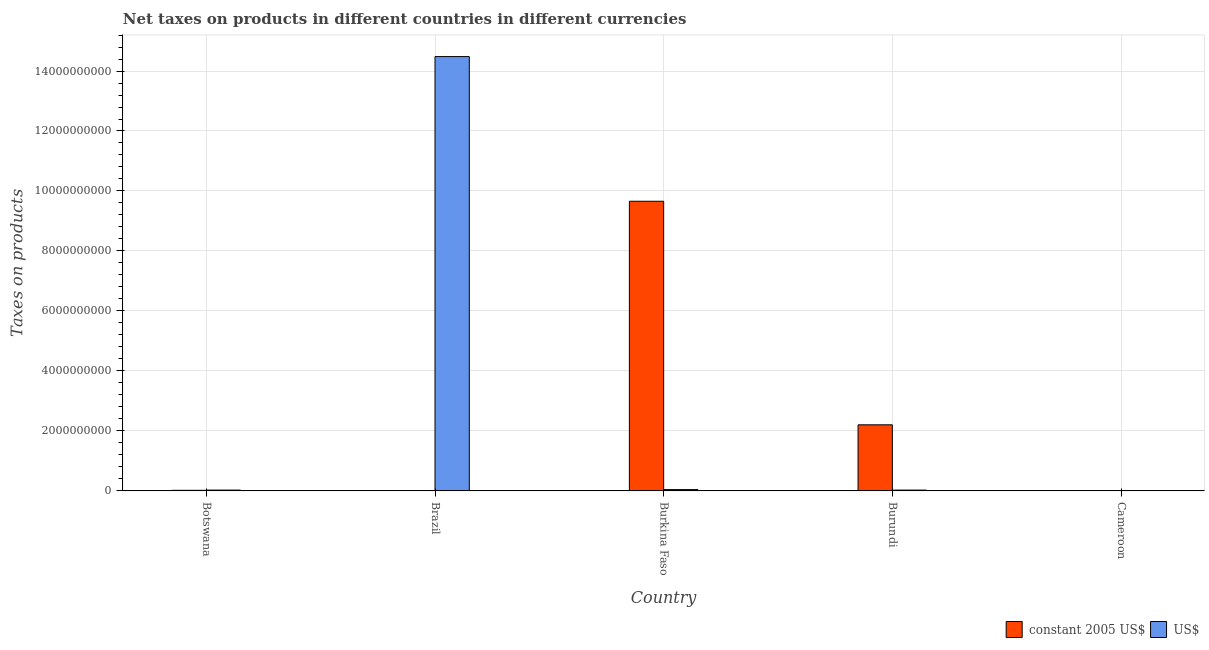How many different coloured bars are there?
Make the answer very short. 2. Are the number of bars per tick equal to the number of legend labels?
Offer a very short reply. No. How many bars are there on the 3rd tick from the left?
Provide a succinct answer. 2. How many bars are there on the 4th tick from the right?
Give a very brief answer. 2. What is the net taxes in constant 2005 us$ in Cameroon?
Your answer should be compact. 0. Across all countries, what is the maximum net taxes in constant 2005 us$?
Offer a terse response. 9.66e+09. Across all countries, what is the minimum net taxes in constant 2005 us$?
Provide a succinct answer. 0. In which country was the net taxes in us$ maximum?
Offer a terse response. Brazil. What is the total net taxes in constant 2005 us$ in the graph?
Ensure brevity in your answer.  1.19e+1. What is the difference between the net taxes in us$ in Botswana and that in Burkina Faso?
Your answer should be very brief. -1.73e+07. What is the difference between the net taxes in constant 2005 us$ in Botswana and the net taxes in us$ in Cameroon?
Offer a terse response. 2.05e+07. What is the average net taxes in us$ per country?
Ensure brevity in your answer.  2.92e+09. What is the difference between the net taxes in us$ and net taxes in constant 2005 us$ in Brazil?
Offer a terse response. 1.45e+1. What is the ratio of the net taxes in constant 2005 us$ in Botswana to that in Burkina Faso?
Offer a very short reply. 0. What is the difference between the highest and the second highest net taxes in us$?
Give a very brief answer. 1.44e+1. What is the difference between the highest and the lowest net taxes in constant 2005 us$?
Provide a short and direct response. 9.66e+09. How many bars are there?
Ensure brevity in your answer.  8. Are the values on the major ticks of Y-axis written in scientific E-notation?
Your response must be concise. No. Does the graph contain grids?
Provide a short and direct response. Yes. How are the legend labels stacked?
Give a very brief answer. Horizontal. What is the title of the graph?
Keep it short and to the point. Net taxes on products in different countries in different currencies. What is the label or title of the Y-axis?
Keep it short and to the point. Taxes on products. What is the Taxes on products of constant 2005 US$ in Botswana?
Your answer should be compact. 2.05e+07. What is the Taxes on products in US$ in Botswana?
Give a very brief answer. 2.77e+07. What is the Taxes on products of constant 2005 US$ in Brazil?
Offer a very short reply. 0.04. What is the Taxes on products in US$ in Brazil?
Offer a terse response. 1.45e+1. What is the Taxes on products of constant 2005 US$ in Burkina Faso?
Provide a short and direct response. 9.66e+09. What is the Taxes on products in US$ in Burkina Faso?
Your response must be concise. 4.51e+07. What is the Taxes on products in constant 2005 US$ in Burundi?
Keep it short and to the point. 2.20e+09. What is the Taxes on products of US$ in Burundi?
Keep it short and to the point. 2.80e+07. Across all countries, what is the maximum Taxes on products of constant 2005 US$?
Your answer should be very brief. 9.66e+09. Across all countries, what is the maximum Taxes on products of US$?
Give a very brief answer. 1.45e+1. Across all countries, what is the minimum Taxes on products of US$?
Offer a terse response. 0. What is the total Taxes on products of constant 2005 US$ in the graph?
Provide a short and direct response. 1.19e+1. What is the total Taxes on products of US$ in the graph?
Make the answer very short. 1.46e+1. What is the difference between the Taxes on products of constant 2005 US$ in Botswana and that in Brazil?
Make the answer very short. 2.05e+07. What is the difference between the Taxes on products of US$ in Botswana and that in Brazil?
Provide a succinct answer. -1.45e+1. What is the difference between the Taxes on products in constant 2005 US$ in Botswana and that in Burkina Faso?
Offer a terse response. -9.64e+09. What is the difference between the Taxes on products of US$ in Botswana and that in Burkina Faso?
Your answer should be very brief. -1.73e+07. What is the difference between the Taxes on products in constant 2005 US$ in Botswana and that in Burundi?
Keep it short and to the point. -2.18e+09. What is the difference between the Taxes on products of US$ in Botswana and that in Burundi?
Offer a very short reply. -2.74e+05. What is the difference between the Taxes on products in constant 2005 US$ in Brazil and that in Burkina Faso?
Offer a very short reply. -9.66e+09. What is the difference between the Taxes on products of US$ in Brazil and that in Burkina Faso?
Keep it short and to the point. 1.44e+1. What is the difference between the Taxes on products of constant 2005 US$ in Brazil and that in Burundi?
Ensure brevity in your answer.  -2.20e+09. What is the difference between the Taxes on products in US$ in Brazil and that in Burundi?
Make the answer very short. 1.45e+1. What is the difference between the Taxes on products of constant 2005 US$ in Burkina Faso and that in Burundi?
Your response must be concise. 7.45e+09. What is the difference between the Taxes on products in US$ in Burkina Faso and that in Burundi?
Your response must be concise. 1.71e+07. What is the difference between the Taxes on products of constant 2005 US$ in Botswana and the Taxes on products of US$ in Brazil?
Ensure brevity in your answer.  -1.45e+1. What is the difference between the Taxes on products of constant 2005 US$ in Botswana and the Taxes on products of US$ in Burkina Faso?
Your response must be concise. -2.46e+07. What is the difference between the Taxes on products in constant 2005 US$ in Botswana and the Taxes on products in US$ in Burundi?
Keep it short and to the point. -7.49e+06. What is the difference between the Taxes on products of constant 2005 US$ in Brazil and the Taxes on products of US$ in Burkina Faso?
Offer a very short reply. -4.51e+07. What is the difference between the Taxes on products of constant 2005 US$ in Brazil and the Taxes on products of US$ in Burundi?
Make the answer very short. -2.80e+07. What is the difference between the Taxes on products of constant 2005 US$ in Burkina Faso and the Taxes on products of US$ in Burundi?
Make the answer very short. 9.63e+09. What is the average Taxes on products in constant 2005 US$ per country?
Provide a succinct answer. 2.38e+09. What is the average Taxes on products in US$ per country?
Keep it short and to the point. 2.92e+09. What is the difference between the Taxes on products of constant 2005 US$ and Taxes on products of US$ in Botswana?
Offer a terse response. -7.22e+06. What is the difference between the Taxes on products in constant 2005 US$ and Taxes on products in US$ in Brazil?
Give a very brief answer. -1.45e+1. What is the difference between the Taxes on products of constant 2005 US$ and Taxes on products of US$ in Burkina Faso?
Make the answer very short. 9.61e+09. What is the difference between the Taxes on products in constant 2005 US$ and Taxes on products in US$ in Burundi?
Give a very brief answer. 2.18e+09. What is the ratio of the Taxes on products of constant 2005 US$ in Botswana to that in Brazil?
Offer a terse response. 4.79e+08. What is the ratio of the Taxes on products in US$ in Botswana to that in Brazil?
Offer a very short reply. 0. What is the ratio of the Taxes on products in constant 2005 US$ in Botswana to that in Burkina Faso?
Make the answer very short. 0. What is the ratio of the Taxes on products of US$ in Botswana to that in Burkina Faso?
Offer a terse response. 0.62. What is the ratio of the Taxes on products in constant 2005 US$ in Botswana to that in Burundi?
Your response must be concise. 0.01. What is the ratio of the Taxes on products in US$ in Botswana to that in Burundi?
Make the answer very short. 0.99. What is the ratio of the Taxes on products of US$ in Brazil to that in Burkina Faso?
Ensure brevity in your answer.  321.33. What is the ratio of the Taxes on products of US$ in Brazil to that in Burundi?
Your answer should be very brief. 517.26. What is the ratio of the Taxes on products of constant 2005 US$ in Burkina Faso to that in Burundi?
Give a very brief answer. 4.38. What is the ratio of the Taxes on products in US$ in Burkina Faso to that in Burundi?
Your answer should be compact. 1.61. What is the difference between the highest and the second highest Taxes on products in constant 2005 US$?
Ensure brevity in your answer.  7.45e+09. What is the difference between the highest and the second highest Taxes on products in US$?
Provide a succinct answer. 1.44e+1. What is the difference between the highest and the lowest Taxes on products of constant 2005 US$?
Keep it short and to the point. 9.66e+09. What is the difference between the highest and the lowest Taxes on products of US$?
Offer a very short reply. 1.45e+1. 